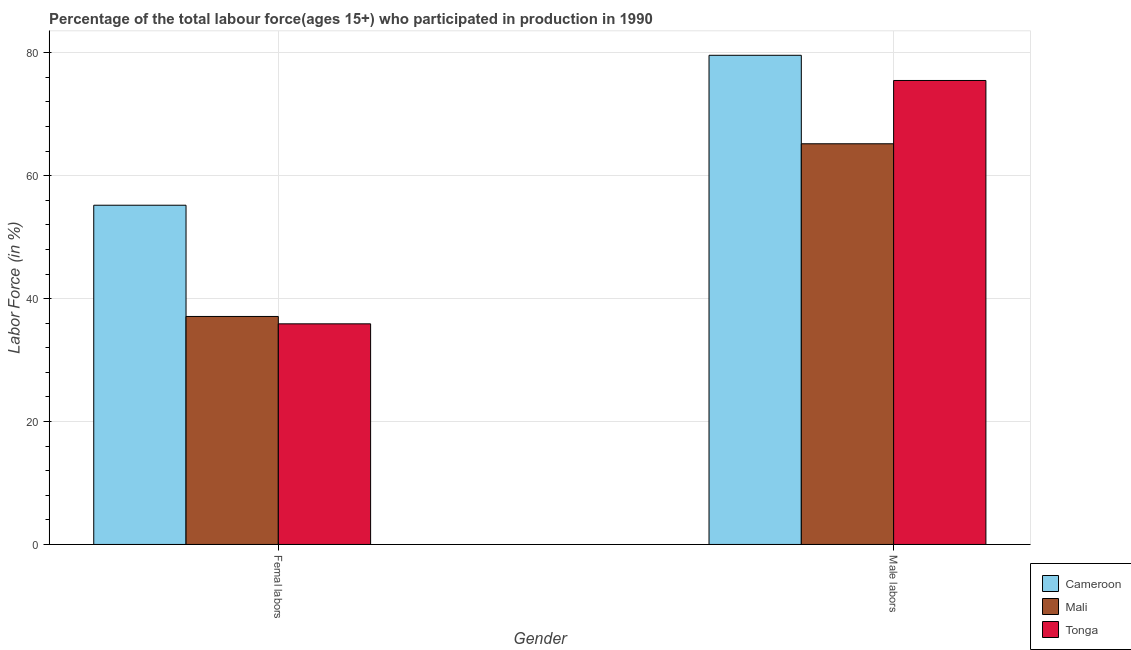Are the number of bars on each tick of the X-axis equal?
Provide a short and direct response. Yes. How many bars are there on the 1st tick from the left?
Offer a terse response. 3. How many bars are there on the 1st tick from the right?
Offer a terse response. 3. What is the label of the 1st group of bars from the left?
Ensure brevity in your answer.  Femal labors. What is the percentage of male labour force in Mali?
Provide a succinct answer. 65.2. Across all countries, what is the maximum percentage of female labor force?
Provide a short and direct response. 55.2. Across all countries, what is the minimum percentage of male labour force?
Make the answer very short. 65.2. In which country was the percentage of female labor force maximum?
Give a very brief answer. Cameroon. In which country was the percentage of female labor force minimum?
Give a very brief answer. Tonga. What is the total percentage of male labour force in the graph?
Offer a terse response. 220.3. What is the difference between the percentage of male labour force in Tonga and that in Mali?
Your answer should be compact. 10.3. What is the difference between the percentage of female labor force in Mali and the percentage of male labour force in Cameroon?
Your response must be concise. -42.5. What is the average percentage of female labor force per country?
Provide a succinct answer. 42.73. What is the difference between the percentage of male labour force and percentage of female labor force in Mali?
Your answer should be very brief. 28.1. In how many countries, is the percentage of male labour force greater than 4 %?
Ensure brevity in your answer.  3. What is the ratio of the percentage of male labour force in Tonga to that in Mali?
Your response must be concise. 1.16. Is the percentage of female labor force in Cameroon less than that in Mali?
Your answer should be compact. No. What does the 2nd bar from the left in Femal labors represents?
Provide a short and direct response. Mali. What does the 1st bar from the right in Male labors represents?
Offer a very short reply. Tonga. What is the difference between two consecutive major ticks on the Y-axis?
Provide a short and direct response. 20. Are the values on the major ticks of Y-axis written in scientific E-notation?
Offer a terse response. No. Where does the legend appear in the graph?
Your answer should be very brief. Bottom right. How many legend labels are there?
Keep it short and to the point. 3. How are the legend labels stacked?
Keep it short and to the point. Vertical. What is the title of the graph?
Ensure brevity in your answer.  Percentage of the total labour force(ages 15+) who participated in production in 1990. What is the label or title of the X-axis?
Offer a terse response. Gender. What is the label or title of the Y-axis?
Provide a short and direct response. Labor Force (in %). What is the Labor Force (in %) in Cameroon in Femal labors?
Keep it short and to the point. 55.2. What is the Labor Force (in %) in Mali in Femal labors?
Your answer should be compact. 37.1. What is the Labor Force (in %) of Tonga in Femal labors?
Offer a very short reply. 35.9. What is the Labor Force (in %) of Cameroon in Male labors?
Provide a short and direct response. 79.6. What is the Labor Force (in %) of Mali in Male labors?
Your response must be concise. 65.2. What is the Labor Force (in %) of Tonga in Male labors?
Offer a terse response. 75.5. Across all Gender, what is the maximum Labor Force (in %) of Cameroon?
Offer a terse response. 79.6. Across all Gender, what is the maximum Labor Force (in %) in Mali?
Provide a short and direct response. 65.2. Across all Gender, what is the maximum Labor Force (in %) of Tonga?
Make the answer very short. 75.5. Across all Gender, what is the minimum Labor Force (in %) in Cameroon?
Keep it short and to the point. 55.2. Across all Gender, what is the minimum Labor Force (in %) in Mali?
Your response must be concise. 37.1. Across all Gender, what is the minimum Labor Force (in %) of Tonga?
Your answer should be very brief. 35.9. What is the total Labor Force (in %) of Cameroon in the graph?
Provide a succinct answer. 134.8. What is the total Labor Force (in %) of Mali in the graph?
Keep it short and to the point. 102.3. What is the total Labor Force (in %) in Tonga in the graph?
Give a very brief answer. 111.4. What is the difference between the Labor Force (in %) of Cameroon in Femal labors and that in Male labors?
Make the answer very short. -24.4. What is the difference between the Labor Force (in %) in Mali in Femal labors and that in Male labors?
Your answer should be compact. -28.1. What is the difference between the Labor Force (in %) of Tonga in Femal labors and that in Male labors?
Ensure brevity in your answer.  -39.6. What is the difference between the Labor Force (in %) of Cameroon in Femal labors and the Labor Force (in %) of Mali in Male labors?
Make the answer very short. -10. What is the difference between the Labor Force (in %) of Cameroon in Femal labors and the Labor Force (in %) of Tonga in Male labors?
Your response must be concise. -20.3. What is the difference between the Labor Force (in %) of Mali in Femal labors and the Labor Force (in %) of Tonga in Male labors?
Your answer should be compact. -38.4. What is the average Labor Force (in %) of Cameroon per Gender?
Offer a terse response. 67.4. What is the average Labor Force (in %) in Mali per Gender?
Your answer should be very brief. 51.15. What is the average Labor Force (in %) in Tonga per Gender?
Offer a terse response. 55.7. What is the difference between the Labor Force (in %) of Cameroon and Labor Force (in %) of Tonga in Femal labors?
Offer a very short reply. 19.3. What is the difference between the Labor Force (in %) of Mali and Labor Force (in %) of Tonga in Femal labors?
Provide a short and direct response. 1.2. What is the difference between the Labor Force (in %) in Mali and Labor Force (in %) in Tonga in Male labors?
Your answer should be very brief. -10.3. What is the ratio of the Labor Force (in %) of Cameroon in Femal labors to that in Male labors?
Your answer should be very brief. 0.69. What is the ratio of the Labor Force (in %) of Mali in Femal labors to that in Male labors?
Keep it short and to the point. 0.57. What is the ratio of the Labor Force (in %) of Tonga in Femal labors to that in Male labors?
Offer a terse response. 0.48. What is the difference between the highest and the second highest Labor Force (in %) of Cameroon?
Offer a very short reply. 24.4. What is the difference between the highest and the second highest Labor Force (in %) in Mali?
Your answer should be compact. 28.1. What is the difference between the highest and the second highest Labor Force (in %) in Tonga?
Give a very brief answer. 39.6. What is the difference between the highest and the lowest Labor Force (in %) in Cameroon?
Keep it short and to the point. 24.4. What is the difference between the highest and the lowest Labor Force (in %) of Mali?
Give a very brief answer. 28.1. What is the difference between the highest and the lowest Labor Force (in %) of Tonga?
Make the answer very short. 39.6. 